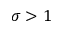Convert formula to latex. <formula><loc_0><loc_0><loc_500><loc_500>\sigma > 1</formula> 